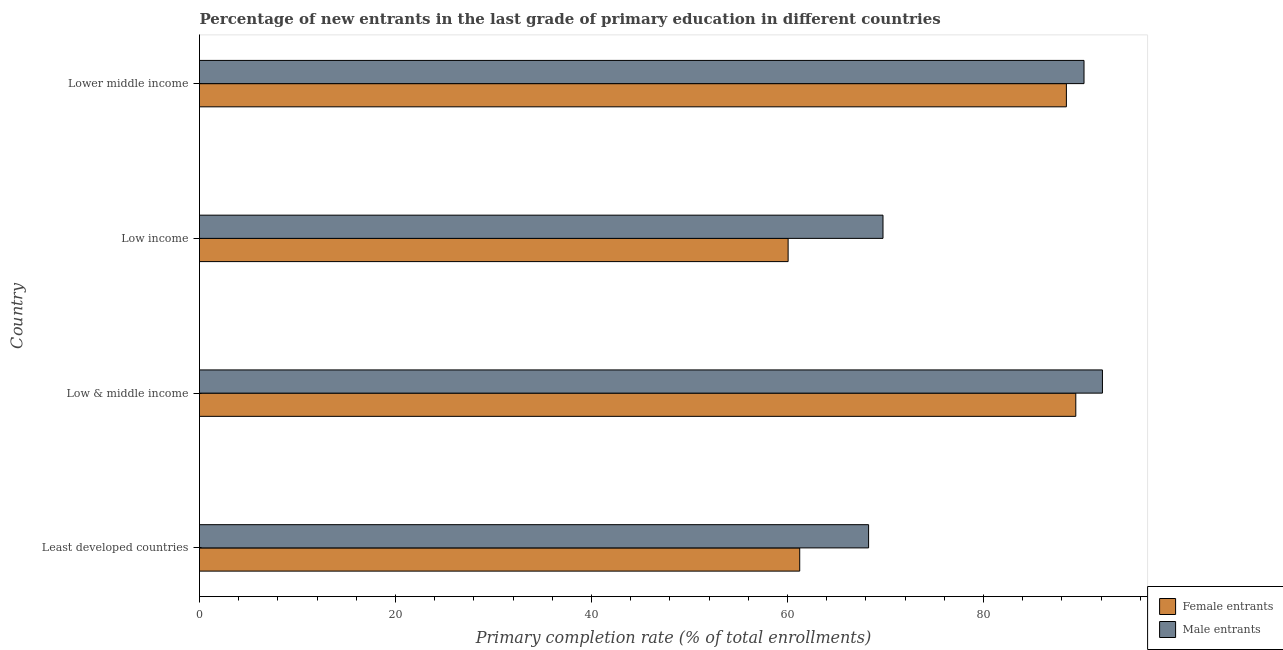How many different coloured bars are there?
Offer a terse response. 2. How many bars are there on the 4th tick from the bottom?
Make the answer very short. 2. What is the label of the 3rd group of bars from the top?
Your answer should be compact. Low & middle income. In how many cases, is the number of bars for a given country not equal to the number of legend labels?
Provide a short and direct response. 0. What is the primary completion rate of male entrants in Least developed countries?
Give a very brief answer. 68.28. Across all countries, what is the maximum primary completion rate of female entrants?
Provide a succinct answer. 89.42. Across all countries, what is the minimum primary completion rate of female entrants?
Your response must be concise. 60.07. In which country was the primary completion rate of male entrants minimum?
Make the answer very short. Least developed countries. What is the total primary completion rate of male entrants in the graph?
Your response must be concise. 320.44. What is the difference between the primary completion rate of male entrants in Least developed countries and that in Lower middle income?
Your answer should be very brief. -21.98. What is the difference between the primary completion rate of male entrants in Least developed countries and the primary completion rate of female entrants in Low income?
Ensure brevity in your answer.  8.21. What is the average primary completion rate of female entrants per country?
Your response must be concise. 74.8. What is the difference between the primary completion rate of male entrants and primary completion rate of female entrants in Low & middle income?
Provide a succinct answer. 2.72. What is the ratio of the primary completion rate of female entrants in Least developed countries to that in Low & middle income?
Make the answer very short. 0.69. What is the difference between the highest and the second highest primary completion rate of male entrants?
Provide a succinct answer. 1.88. What is the difference between the highest and the lowest primary completion rate of female entrants?
Your response must be concise. 29.36. Is the sum of the primary completion rate of female entrants in Low & middle income and Lower middle income greater than the maximum primary completion rate of male entrants across all countries?
Your response must be concise. Yes. What does the 1st bar from the top in Least developed countries represents?
Keep it short and to the point. Male entrants. What does the 1st bar from the bottom in Least developed countries represents?
Give a very brief answer. Female entrants. How many bars are there?
Make the answer very short. 8. What is the difference between two consecutive major ticks on the X-axis?
Your response must be concise. 20. How many legend labels are there?
Your response must be concise. 2. How are the legend labels stacked?
Keep it short and to the point. Vertical. What is the title of the graph?
Provide a succinct answer. Percentage of new entrants in the last grade of primary education in different countries. What is the label or title of the X-axis?
Keep it short and to the point. Primary completion rate (% of total enrollments). What is the label or title of the Y-axis?
Your response must be concise. Country. What is the Primary completion rate (% of total enrollments) of Female entrants in Least developed countries?
Ensure brevity in your answer.  61.25. What is the Primary completion rate (% of total enrollments) in Male entrants in Least developed countries?
Provide a short and direct response. 68.28. What is the Primary completion rate (% of total enrollments) of Female entrants in Low & middle income?
Your response must be concise. 89.42. What is the Primary completion rate (% of total enrollments) in Male entrants in Low & middle income?
Keep it short and to the point. 92.14. What is the Primary completion rate (% of total enrollments) in Female entrants in Low income?
Provide a succinct answer. 60.07. What is the Primary completion rate (% of total enrollments) in Male entrants in Low income?
Offer a very short reply. 69.75. What is the Primary completion rate (% of total enrollments) of Female entrants in Lower middle income?
Offer a terse response. 88.46. What is the Primary completion rate (% of total enrollments) of Male entrants in Lower middle income?
Make the answer very short. 90.26. Across all countries, what is the maximum Primary completion rate (% of total enrollments) in Female entrants?
Keep it short and to the point. 89.42. Across all countries, what is the maximum Primary completion rate (% of total enrollments) of Male entrants?
Ensure brevity in your answer.  92.14. Across all countries, what is the minimum Primary completion rate (% of total enrollments) of Female entrants?
Provide a succinct answer. 60.07. Across all countries, what is the minimum Primary completion rate (% of total enrollments) of Male entrants?
Your answer should be compact. 68.28. What is the total Primary completion rate (% of total enrollments) of Female entrants in the graph?
Ensure brevity in your answer.  299.21. What is the total Primary completion rate (% of total enrollments) in Male entrants in the graph?
Provide a succinct answer. 320.44. What is the difference between the Primary completion rate (% of total enrollments) in Female entrants in Least developed countries and that in Low & middle income?
Your response must be concise. -28.17. What is the difference between the Primary completion rate (% of total enrollments) in Male entrants in Least developed countries and that in Low & middle income?
Make the answer very short. -23.86. What is the difference between the Primary completion rate (% of total enrollments) in Female entrants in Least developed countries and that in Low income?
Your answer should be compact. 1.18. What is the difference between the Primary completion rate (% of total enrollments) of Male entrants in Least developed countries and that in Low income?
Your answer should be compact. -1.47. What is the difference between the Primary completion rate (% of total enrollments) of Female entrants in Least developed countries and that in Lower middle income?
Keep it short and to the point. -27.21. What is the difference between the Primary completion rate (% of total enrollments) in Male entrants in Least developed countries and that in Lower middle income?
Offer a very short reply. -21.98. What is the difference between the Primary completion rate (% of total enrollments) in Female entrants in Low & middle income and that in Low income?
Provide a short and direct response. 29.36. What is the difference between the Primary completion rate (% of total enrollments) in Male entrants in Low & middle income and that in Low income?
Make the answer very short. 22.39. What is the difference between the Primary completion rate (% of total enrollments) in Male entrants in Low & middle income and that in Lower middle income?
Give a very brief answer. 1.88. What is the difference between the Primary completion rate (% of total enrollments) in Female entrants in Low income and that in Lower middle income?
Offer a very short reply. -28.4. What is the difference between the Primary completion rate (% of total enrollments) in Male entrants in Low income and that in Lower middle income?
Provide a succinct answer. -20.51. What is the difference between the Primary completion rate (% of total enrollments) of Female entrants in Least developed countries and the Primary completion rate (% of total enrollments) of Male entrants in Low & middle income?
Your answer should be compact. -30.89. What is the difference between the Primary completion rate (% of total enrollments) in Female entrants in Least developed countries and the Primary completion rate (% of total enrollments) in Male entrants in Low income?
Your response must be concise. -8.5. What is the difference between the Primary completion rate (% of total enrollments) in Female entrants in Least developed countries and the Primary completion rate (% of total enrollments) in Male entrants in Lower middle income?
Give a very brief answer. -29.01. What is the difference between the Primary completion rate (% of total enrollments) in Female entrants in Low & middle income and the Primary completion rate (% of total enrollments) in Male entrants in Low income?
Keep it short and to the point. 19.67. What is the difference between the Primary completion rate (% of total enrollments) in Female entrants in Low & middle income and the Primary completion rate (% of total enrollments) in Male entrants in Lower middle income?
Your answer should be very brief. -0.84. What is the difference between the Primary completion rate (% of total enrollments) in Female entrants in Low income and the Primary completion rate (% of total enrollments) in Male entrants in Lower middle income?
Ensure brevity in your answer.  -30.2. What is the average Primary completion rate (% of total enrollments) of Female entrants per country?
Provide a short and direct response. 74.8. What is the average Primary completion rate (% of total enrollments) in Male entrants per country?
Offer a very short reply. 80.11. What is the difference between the Primary completion rate (% of total enrollments) in Female entrants and Primary completion rate (% of total enrollments) in Male entrants in Least developed countries?
Offer a terse response. -7.03. What is the difference between the Primary completion rate (% of total enrollments) in Female entrants and Primary completion rate (% of total enrollments) in Male entrants in Low & middle income?
Give a very brief answer. -2.72. What is the difference between the Primary completion rate (% of total enrollments) of Female entrants and Primary completion rate (% of total enrollments) of Male entrants in Low income?
Provide a short and direct response. -9.68. What is the difference between the Primary completion rate (% of total enrollments) in Female entrants and Primary completion rate (% of total enrollments) in Male entrants in Lower middle income?
Your answer should be very brief. -1.8. What is the ratio of the Primary completion rate (% of total enrollments) of Female entrants in Least developed countries to that in Low & middle income?
Give a very brief answer. 0.68. What is the ratio of the Primary completion rate (% of total enrollments) in Male entrants in Least developed countries to that in Low & middle income?
Offer a terse response. 0.74. What is the ratio of the Primary completion rate (% of total enrollments) in Female entrants in Least developed countries to that in Low income?
Ensure brevity in your answer.  1.02. What is the ratio of the Primary completion rate (% of total enrollments) in Male entrants in Least developed countries to that in Low income?
Keep it short and to the point. 0.98. What is the ratio of the Primary completion rate (% of total enrollments) in Female entrants in Least developed countries to that in Lower middle income?
Your response must be concise. 0.69. What is the ratio of the Primary completion rate (% of total enrollments) in Male entrants in Least developed countries to that in Lower middle income?
Provide a short and direct response. 0.76. What is the ratio of the Primary completion rate (% of total enrollments) in Female entrants in Low & middle income to that in Low income?
Your answer should be compact. 1.49. What is the ratio of the Primary completion rate (% of total enrollments) of Male entrants in Low & middle income to that in Low income?
Make the answer very short. 1.32. What is the ratio of the Primary completion rate (% of total enrollments) in Female entrants in Low & middle income to that in Lower middle income?
Keep it short and to the point. 1.01. What is the ratio of the Primary completion rate (% of total enrollments) in Male entrants in Low & middle income to that in Lower middle income?
Provide a succinct answer. 1.02. What is the ratio of the Primary completion rate (% of total enrollments) of Female entrants in Low income to that in Lower middle income?
Provide a succinct answer. 0.68. What is the ratio of the Primary completion rate (% of total enrollments) in Male entrants in Low income to that in Lower middle income?
Give a very brief answer. 0.77. What is the difference between the highest and the second highest Primary completion rate (% of total enrollments) of Male entrants?
Ensure brevity in your answer.  1.88. What is the difference between the highest and the lowest Primary completion rate (% of total enrollments) in Female entrants?
Ensure brevity in your answer.  29.36. What is the difference between the highest and the lowest Primary completion rate (% of total enrollments) of Male entrants?
Offer a very short reply. 23.86. 